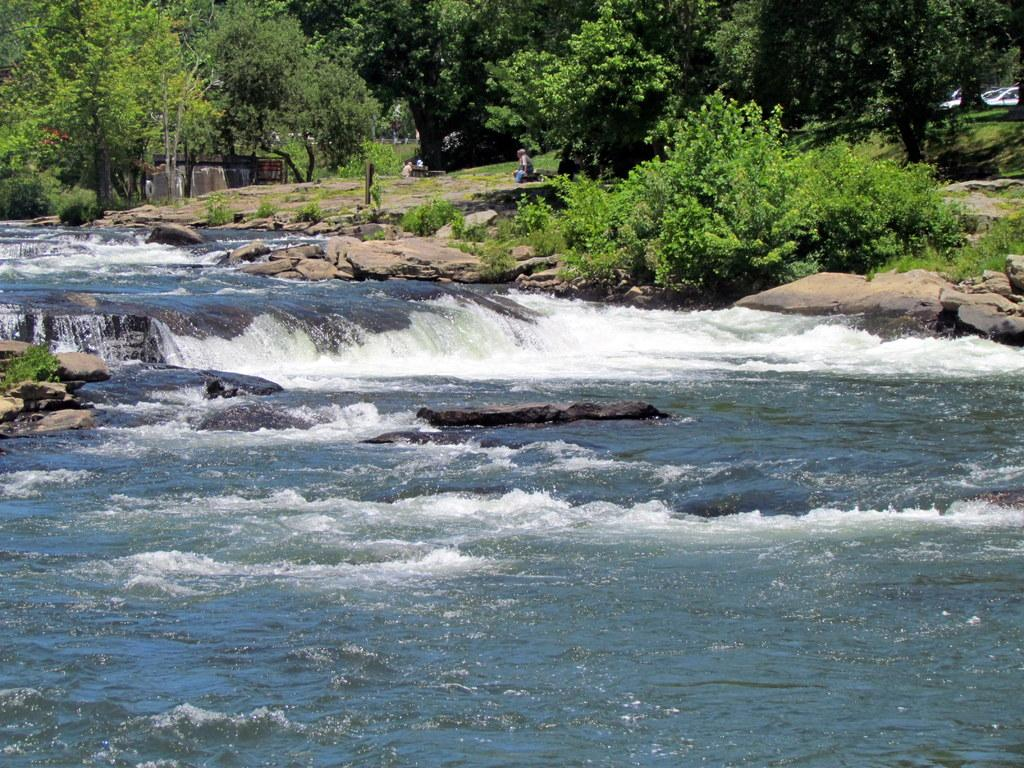What is the primary element present in the image? There is water in the image. What other objects or features can be seen in the image? There are stones and trees in the image. Is there any sign of human presence in the image? Yes, there is a person sitting on the ground in the image. Can you see a kitten playing with a quill near the clover in the image? No, there is no kitten, quill, or clover present in the image. 